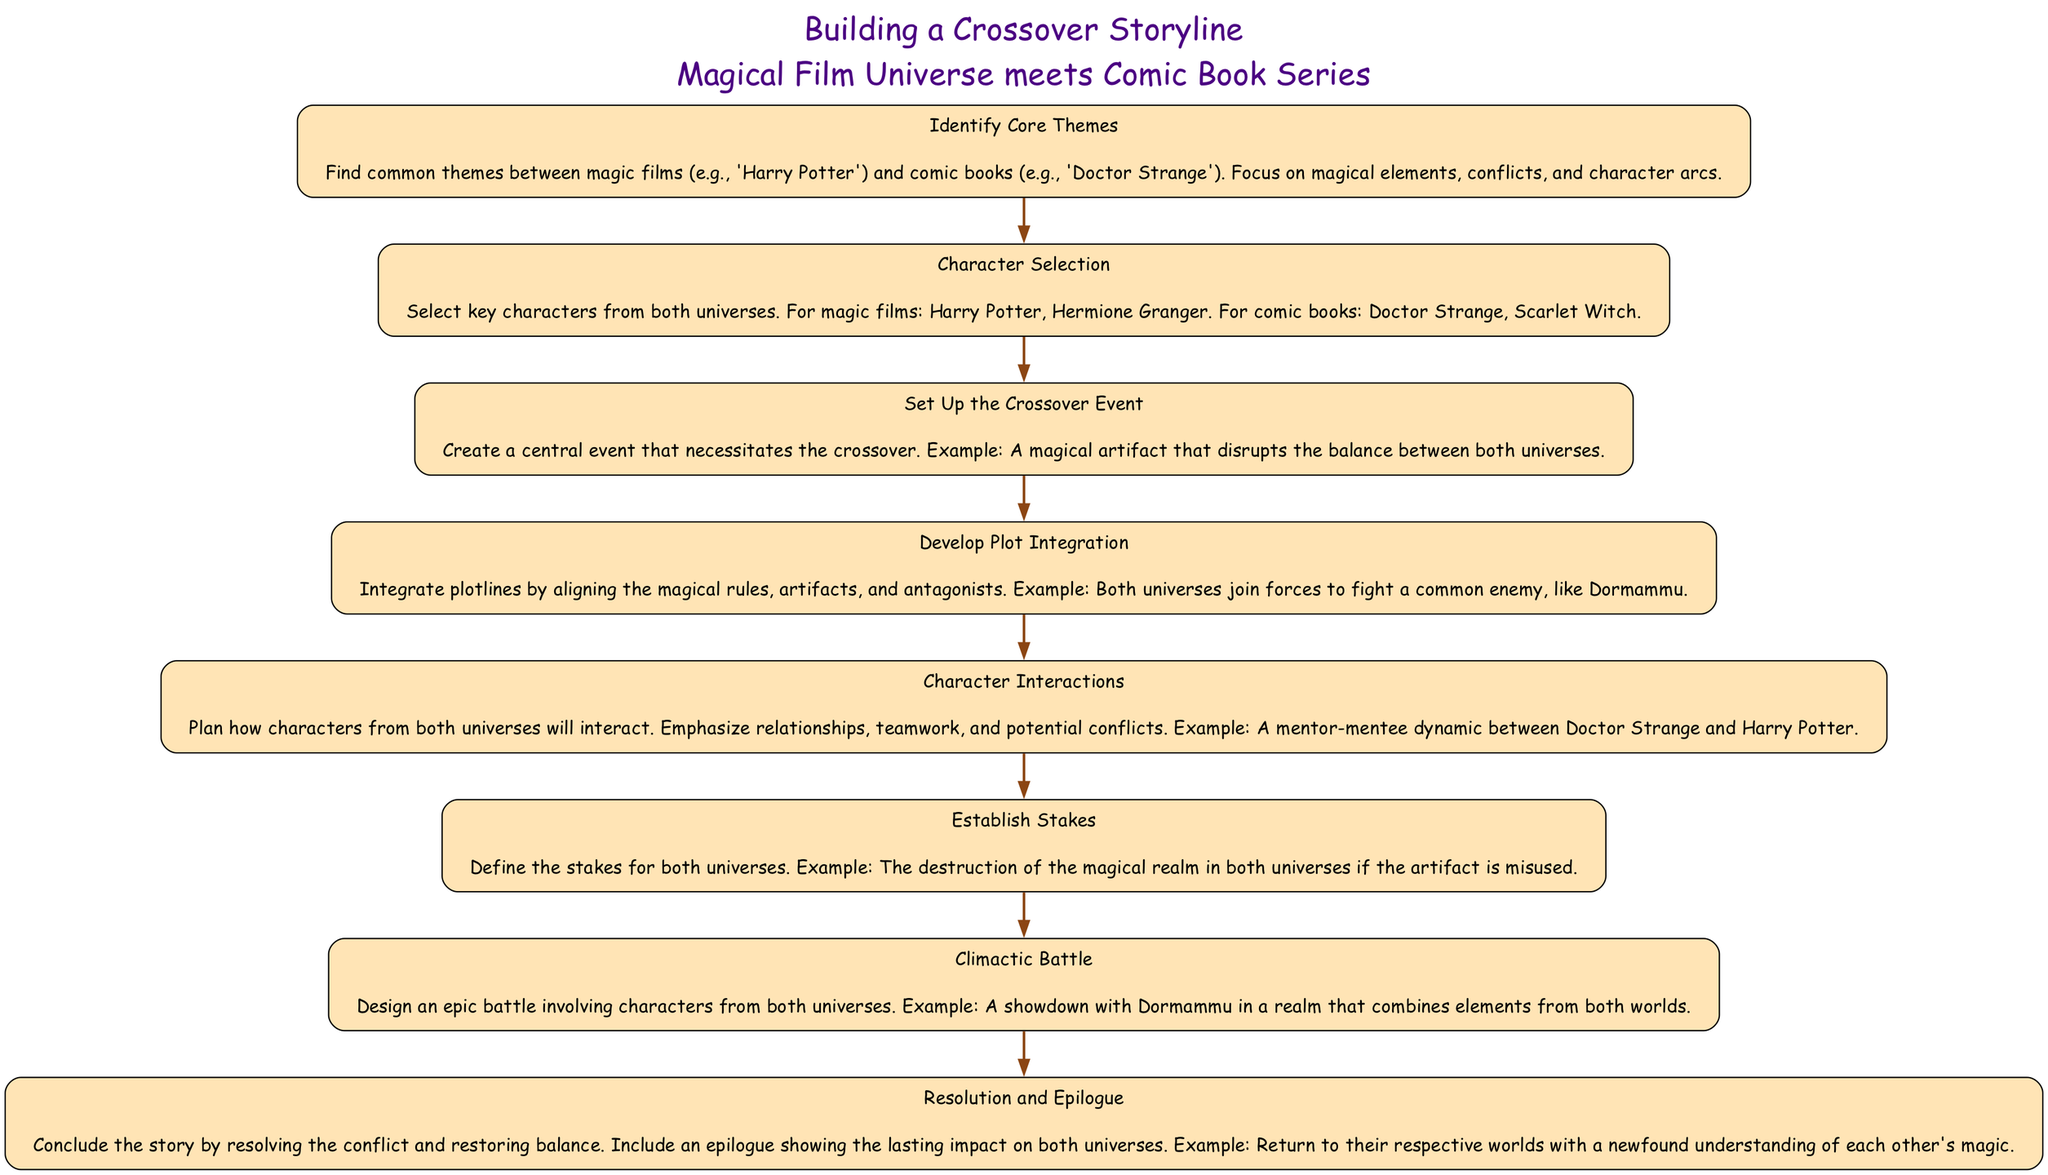What is the first step in the flow chart? The first step in the flow chart is listed as "Identify Core Themes," which is the starting point for building the crossover storyline.
Answer: Identify Core Themes How many characters are selected from the comic book universe? The diagram specifies that there are two characters selected from the comic book universe: Doctor Strange and Scarlet Witch.
Answer: Two What is the central event of the crossover? The central event that necessitates the crossover is described as "A magical artifact that disrupts the balance between both universes."
Answer: A magical artifact that disrupts the balance between both universes Which two characters are emphasized for their interactions? The diagram highlights the interactions between Doctor Strange and Harry Potter, indicating a mentor-mentee dynamic.
Answer: Doctor Strange and Harry Potter What is established in the step before the climactic battle? The step before the climactic battle focuses on establishing the stakes, detailing the consequences if the magical artifact is misused.
Answer: Establish Stakes What is the targeted antagonist for the story? The anticipated antagonist mentioned in the plot integration section is Dormammu, who serves as a common enemy for both universes.
Answer: Dormammu How many steps are there in total? By counting the distinct steps listed in the diagram, it can be determined that there are eight steps in total for the crossover storyline.
Answer: Eight What is the final resolution mentioned in the diagram? The final resolution involves "restoring balance" and providing an epilogue that reflects on the characters' newfound understanding of each other's magic.
Answer: Restoring balance What type of character dynamic is highlighted between Harry Potter and Doctor Strange? The character dynamic emphasized between Harry Potter and Doctor Strange is a mentor-mentee relationship, illustrating their potential collaboration.
Answer: Mentor-mentee dynamic 